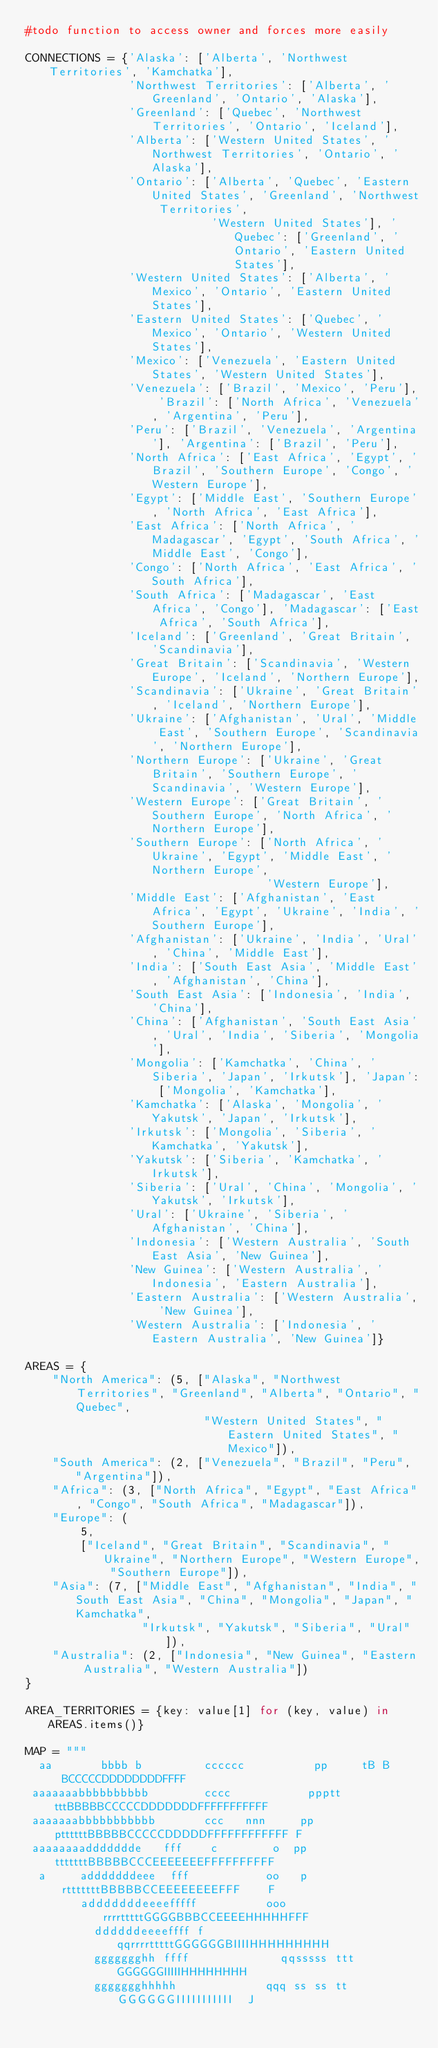Convert code to text. <code><loc_0><loc_0><loc_500><loc_500><_Python_>#todo function to access owner and forces more easily

CONNECTIONS = {'Alaska': ['Alberta', 'Northwest Territories', 'Kamchatka'],
               'Northwest Territories': ['Alberta', 'Greenland', 'Ontario', 'Alaska'],
               'Greenland': ['Quebec', 'Northwest Territories', 'Ontario', 'Iceland'],
               'Alberta': ['Western United States', 'Northwest Territories', 'Ontario', 'Alaska'],
               'Ontario': ['Alberta', 'Quebec', 'Eastern United States', 'Greenland', 'Northwest Territories',
                           'Western United States'], 'Quebec': ['Greenland', 'Ontario', 'Eastern United States'],
               'Western United States': ['Alberta', 'Mexico', 'Ontario', 'Eastern United States'],
               'Eastern United States': ['Quebec', 'Mexico', 'Ontario', 'Western United States'],
               'Mexico': ['Venezuela', 'Eastern United States', 'Western United States'],
               'Venezuela': ['Brazil', 'Mexico', 'Peru'], 'Brazil': ['North Africa', 'Venezuela', 'Argentina', 'Peru'],
               'Peru': ['Brazil', 'Venezuela', 'Argentina'], 'Argentina': ['Brazil', 'Peru'],
               'North Africa': ['East Africa', 'Egypt', 'Brazil', 'Southern Europe', 'Congo', 'Western Europe'],
               'Egypt': ['Middle East', 'Southern Europe', 'North Africa', 'East Africa'],
               'East Africa': ['North Africa', 'Madagascar', 'Egypt', 'South Africa', 'Middle East', 'Congo'],
               'Congo': ['North Africa', 'East Africa', 'South Africa'],
               'South Africa': ['Madagascar', 'East Africa', 'Congo'], 'Madagascar': ['East Africa', 'South Africa'],
               'Iceland': ['Greenland', 'Great Britain', 'Scandinavia'],
               'Great Britain': ['Scandinavia', 'Western Europe', 'Iceland', 'Northern Europe'],
               'Scandinavia': ['Ukraine', 'Great Britain', 'Iceland', 'Northern Europe'],
               'Ukraine': ['Afghanistan', 'Ural', 'Middle East', 'Southern Europe', 'Scandinavia', 'Northern Europe'],
               'Northern Europe': ['Ukraine', 'Great Britain', 'Southern Europe', 'Scandinavia', 'Western Europe'],
               'Western Europe': ['Great Britain', 'Southern Europe', 'North Africa', 'Northern Europe'],
               'Southern Europe': ['North Africa', 'Ukraine', 'Egypt', 'Middle East', 'Northern Europe',
                                   'Western Europe'],
               'Middle East': ['Afghanistan', 'East Africa', 'Egypt', 'Ukraine', 'India', 'Southern Europe'],
               'Afghanistan': ['Ukraine', 'India', 'Ural', 'China', 'Middle East'],
               'India': ['South East Asia', 'Middle East', 'Afghanistan', 'China'],
               'South East Asia': ['Indonesia', 'India', 'China'],
               'China': ['Afghanistan', 'South East Asia', 'Ural', 'India', 'Siberia', 'Mongolia'],
               'Mongolia': ['Kamchatka', 'China', 'Siberia', 'Japan', 'Irkutsk'], 'Japan': ['Mongolia', 'Kamchatka'],
               'Kamchatka': ['Alaska', 'Mongolia', 'Yakutsk', 'Japan', 'Irkutsk'],
               'Irkutsk': ['Mongolia', 'Siberia', 'Kamchatka', 'Yakutsk'],
               'Yakutsk': ['Siberia', 'Kamchatka', 'Irkutsk'],
               'Siberia': ['Ural', 'China', 'Mongolia', 'Yakutsk', 'Irkutsk'],
               'Ural': ['Ukraine', 'Siberia', 'Afghanistan', 'China'],
               'Indonesia': ['Western Australia', 'South East Asia', 'New Guinea'],
               'New Guinea': ['Western Australia', 'Indonesia', 'Eastern Australia'],
               'Eastern Australia': ['Western Australia', 'New Guinea'],
               'Western Australia': ['Indonesia', 'Eastern Australia', 'New Guinea']}

AREAS = {
    "North America": (5, ["Alaska", "Northwest Territories", "Greenland", "Alberta", "Ontario", "Quebec",
                          "Western United States", "Eastern United States", "Mexico"]),
    "South America": (2, ["Venezuela", "Brazil", "Peru", "Argentina"]),
    "Africa": (3, ["North Africa", "Egypt", "East Africa", "Congo", "South Africa", "Madagascar"]),
    "Europe": (
        5,
        ["Iceland", "Great Britain", "Scandinavia", "Ukraine", "Northern Europe", "Western Europe", "Southern Europe"]),
    "Asia": (7, ["Middle East", "Afghanistan", "India", "South East Asia", "China", "Mongolia", "Japan", "Kamchatka",
                 "Irkutsk", "Yakutsk", "Siberia", "Ural"]),
    "Australia": (2, ["Indonesia", "New Guinea", "Eastern Australia", "Western Australia"])
}

AREA_TERRITORIES = {key: value[1] for (key, value) in AREAS.items()}

MAP = """
  aa       bbbb b         cccccc          pp     tB B BCCCCCDDDDDDDDFFFF       
 aaaaaaabbbbbbbbbb        cccc           ppptt tttBBBBBCCCCCDDDDDDDFFFFFFFFFFF 
 aaaaaaabbbbbbbbbbb       ccc   nnn     pp pttttttBBBBBCCCCCDDDDDFFFFFFFFFFFF F
 aaaaaaaaddddddde   fff    c        o  pp  tttttttBBBBBCCCEEEEEEEFFFFFFFFFF    
  a     adddddddeee  fff           oo   p rtttttttBBBBBCCEEEEEEEEFFF    F      
        adddddddeeeefffff          ooo rrrrtttttGGGGBBBCCEEEEHHHHHFFF          
          ddddddeeeeffff f           qqrrrrtttttGGGGGGBIIIIHHHHHHHHH           
          ggggggghh ffff             qqsssss ttt GGGGGGIIIIIHHHHHHHH           
          ggggggghhhhh             qqq ss ss tt  GGGGGGIIIIIIIIIII  J          </code> 